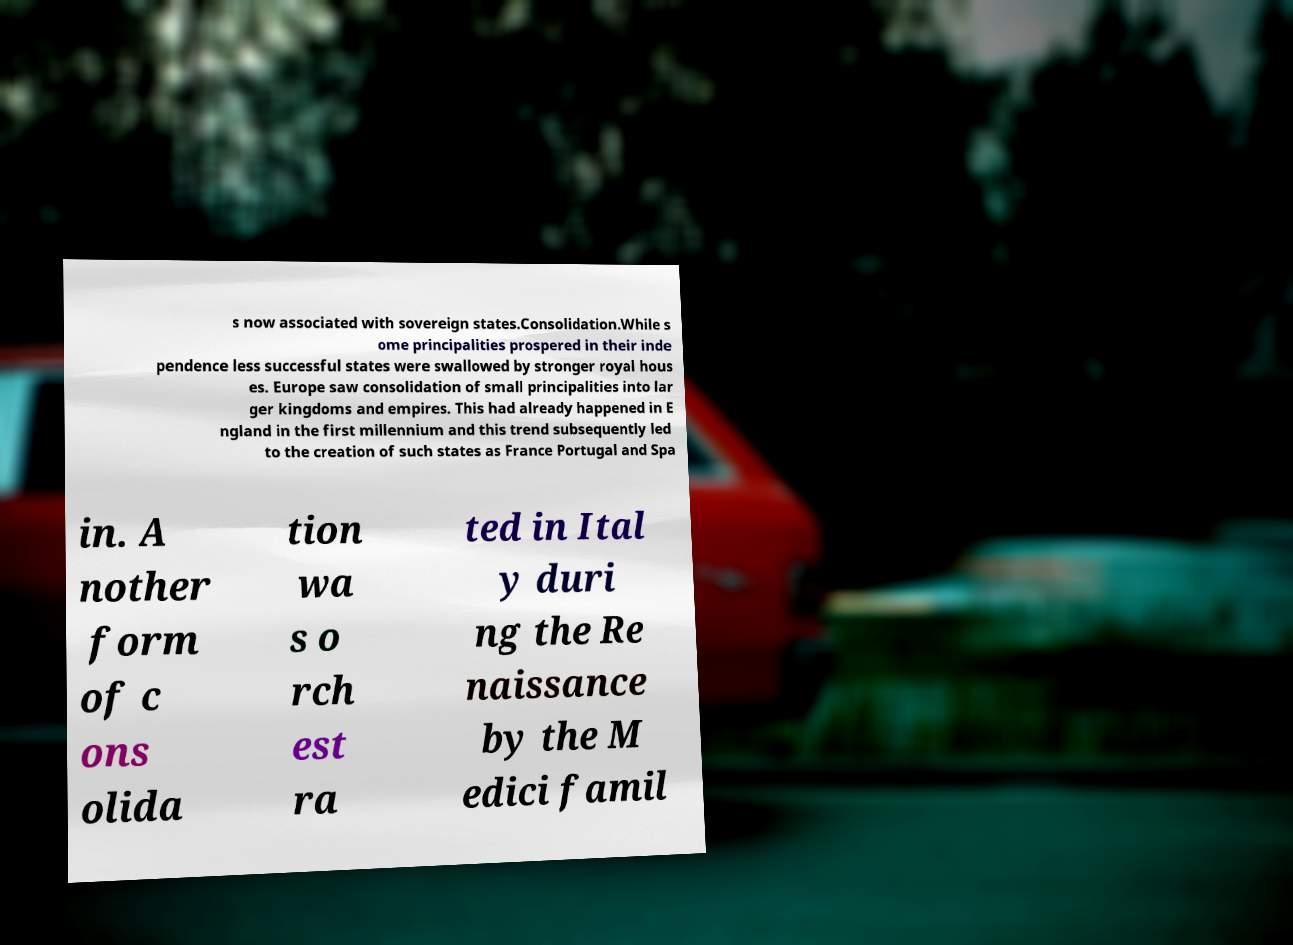There's text embedded in this image that I need extracted. Can you transcribe it verbatim? s now associated with sovereign states.Consolidation.While s ome principalities prospered in their inde pendence less successful states were swallowed by stronger royal hous es. Europe saw consolidation of small principalities into lar ger kingdoms and empires. This had already happened in E ngland in the first millennium and this trend subsequently led to the creation of such states as France Portugal and Spa in. A nother form of c ons olida tion wa s o rch est ra ted in Ital y duri ng the Re naissance by the M edici famil 